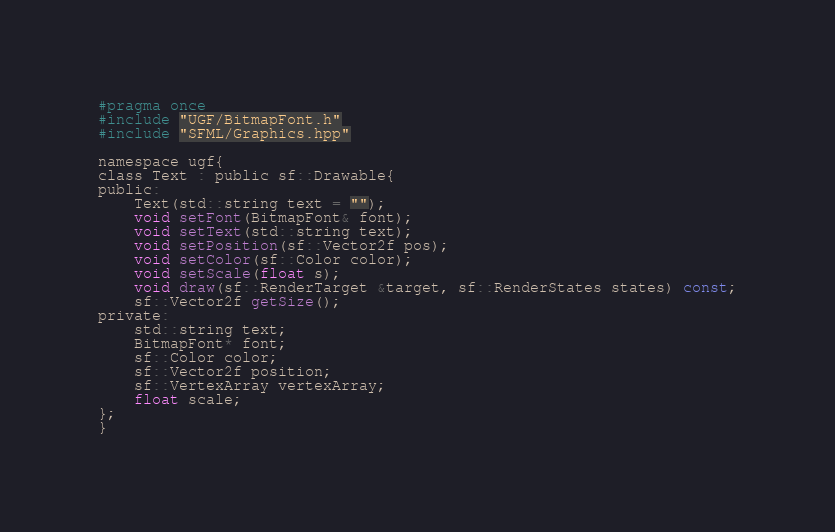Convert code to text. <code><loc_0><loc_0><loc_500><loc_500><_C_>#pragma once
#include "UGF/BitmapFont.h"
#include "SFML/Graphics.hpp"

namespace ugf{
class Text : public sf::Drawable{
public:
    Text(std::string text = "");
    void setFont(BitmapFont& font);
    void setText(std::string text);
    void setPosition(sf::Vector2f pos);
    void setColor(sf::Color color);
    void setScale(float s);
    void draw(sf::RenderTarget &target, sf::RenderStates states) const;
    sf::Vector2f getSize();
private:
    std::string text;
    BitmapFont* font;
    sf::Color color;
    sf::Vector2f position;
    sf::VertexArray vertexArray;
    float scale;
};
}
</code> 